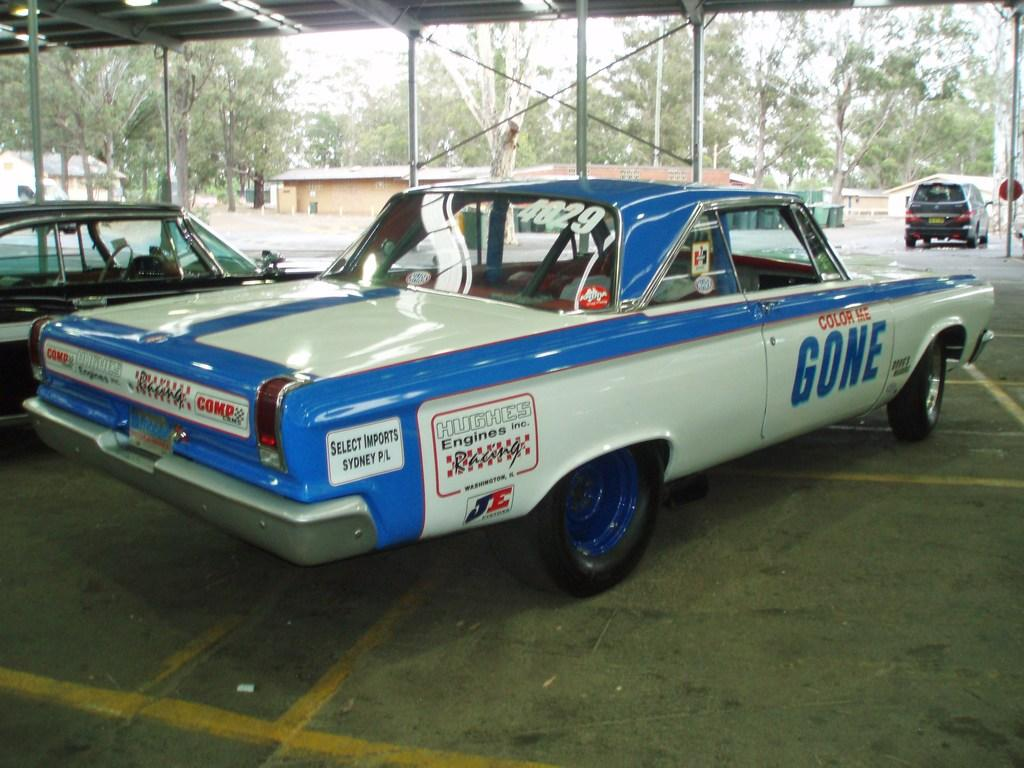What is located under the shed in the image? There are cars under the shed in the image. What can be seen on top of the image? There are lights visible on top of the image. What is visible in the background of the image? There are buildings, trees, and the sky visible in the background of the image. What observation can be made about the journey of the cars in the image? There is no information about the journey of the cars in the image, as it only shows them parked under the shed. What belief is depicted in the image? The image does not depict any specific beliefs; it simply shows cars parked under a shed with lights on top and a background of buildings, trees, and the sky. 